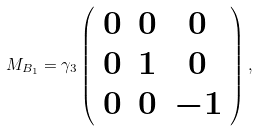Convert formula to latex. <formula><loc_0><loc_0><loc_500><loc_500>M _ { B _ { 1 } } = \gamma _ { 3 } \left ( \begin{array} { c c c } 0 & 0 & 0 \\ 0 & 1 & 0 \\ 0 & 0 & - 1 \end{array} \right ) ,</formula> 